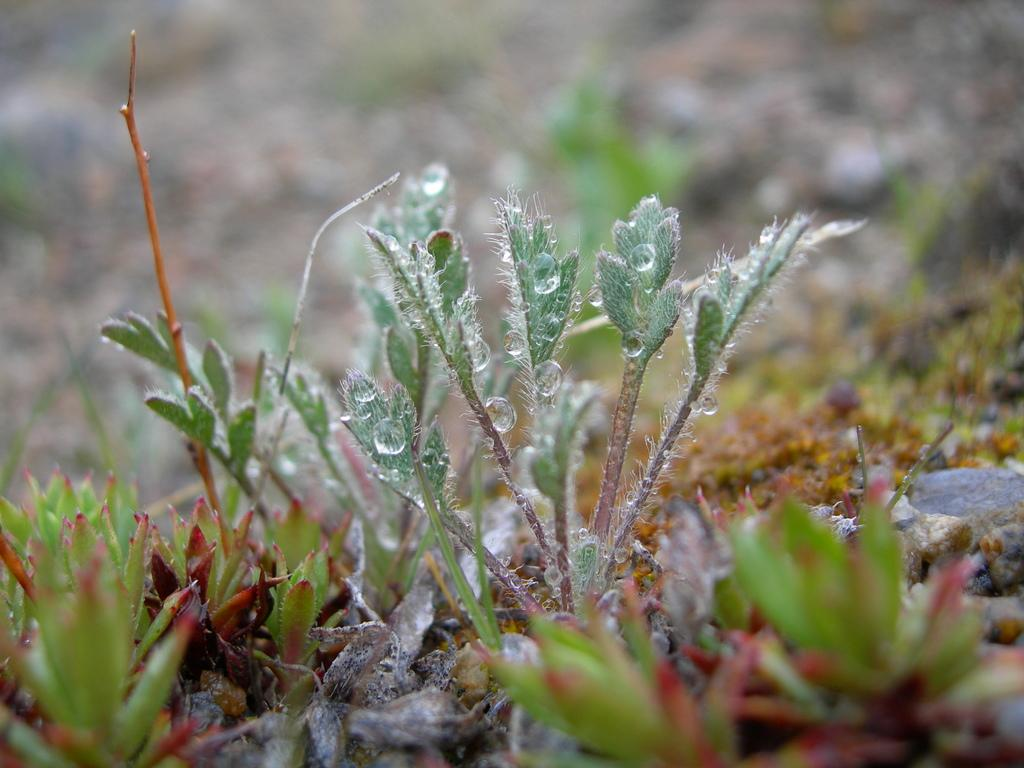What can be seen on the path in the image? There are plants on the path in the image. Can you describe the condition of the plants? Water droplets are visible on a plant in the image. What type of underwear is hanging on the plant in the image? There is no underwear present in the image; it only features plants and water droplets. 